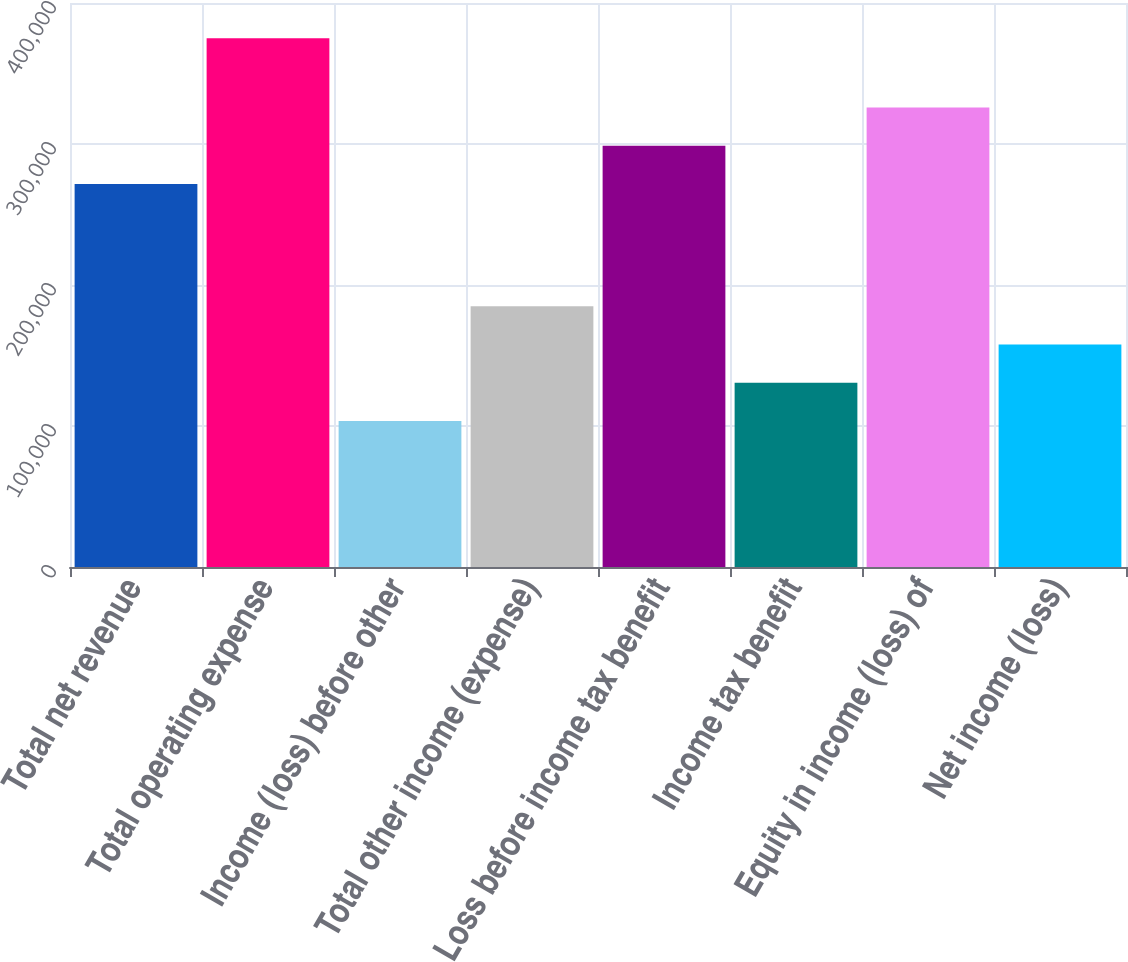Convert chart. <chart><loc_0><loc_0><loc_500><loc_500><bar_chart><fcel>Total net revenue<fcel>Total operating expense<fcel>Income (loss) before other<fcel>Total other income (expense)<fcel>Loss before income tax benefit<fcel>Income tax benefit<fcel>Equity in income (loss) of<fcel>Net income (loss)<nl><fcel>271607<fcel>375083<fcel>103476<fcel>184958<fcel>298768<fcel>130637<fcel>325928<fcel>157797<nl></chart> 